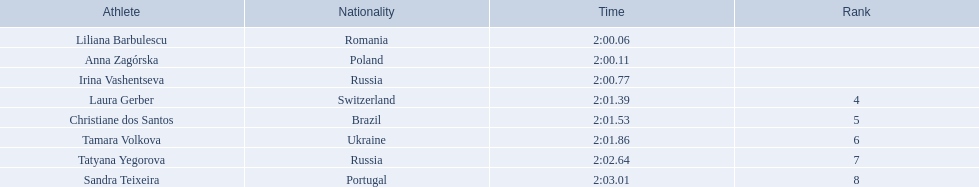Who were the athlete were in the athletics at the 2003 summer universiade - women's 800 metres? , Liliana Barbulescu, Anna Zagórska, Irina Vashentseva, Laura Gerber, Christiane dos Santos, Tamara Volkova, Tatyana Yegorova, Sandra Teixeira. What was anna zagorska finishing time? 2:00.11. 